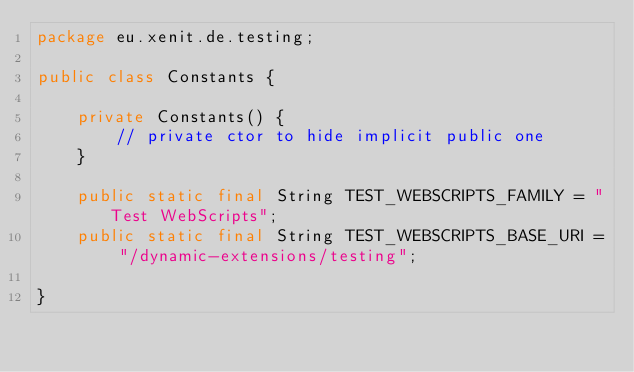<code> <loc_0><loc_0><loc_500><loc_500><_Java_>package eu.xenit.de.testing;

public class Constants {

    private Constants() {
        // private ctor to hide implicit public one
    }

    public static final String TEST_WEBSCRIPTS_FAMILY = "Test WebScripts";
    public static final String TEST_WEBSCRIPTS_BASE_URI = "/dynamic-extensions/testing";

}
</code> 